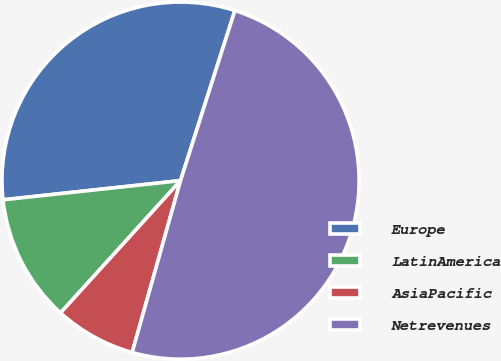Convert chart. <chart><loc_0><loc_0><loc_500><loc_500><pie_chart><fcel>Europe<fcel>LatinAmerica<fcel>AsiaPacific<fcel>Netrevenues<nl><fcel>31.64%<fcel>11.56%<fcel>7.36%<fcel>49.44%<nl></chart> 